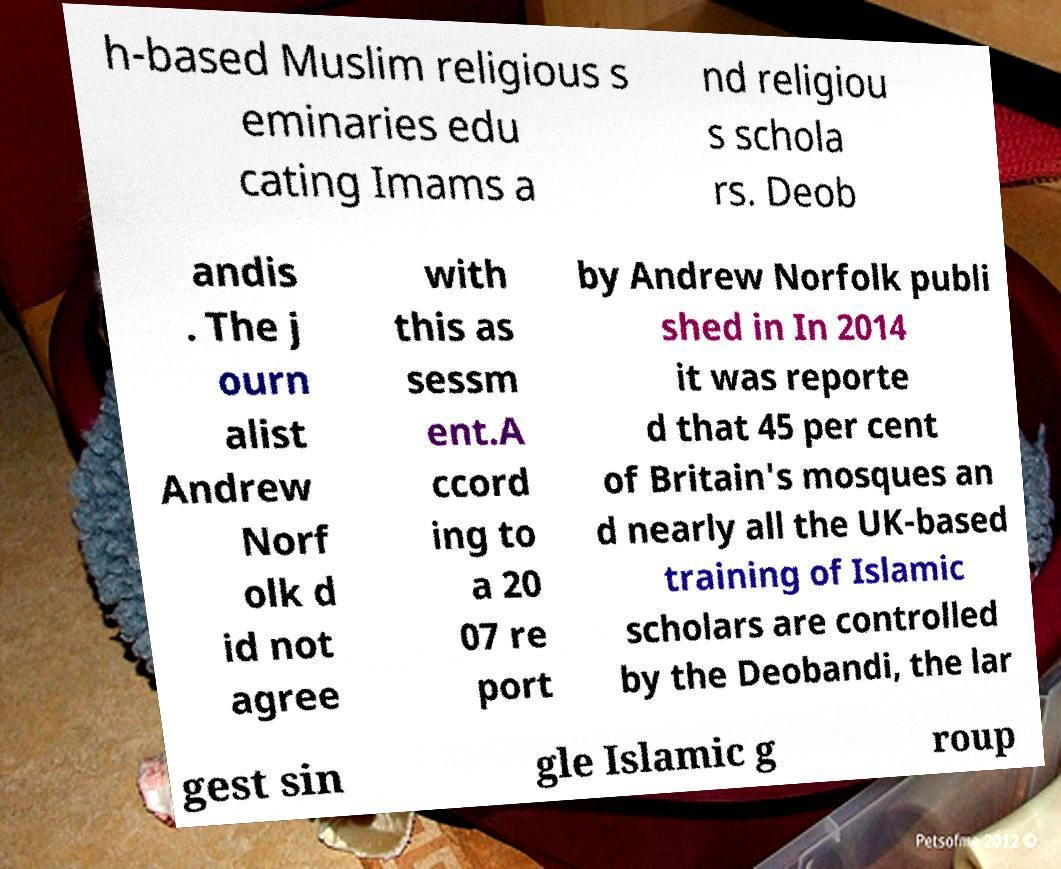Please identify and transcribe the text found in this image. h-based Muslim religious s eminaries edu cating Imams a nd religiou s schola rs. Deob andis . The j ourn alist Andrew Norf olk d id not agree with this as sessm ent.A ccord ing to a 20 07 re port by Andrew Norfolk publi shed in In 2014 it was reporte d that 45 per cent of Britain's mosques an d nearly all the UK-based training of Islamic scholars are controlled by the Deobandi, the lar gest sin gle Islamic g roup 